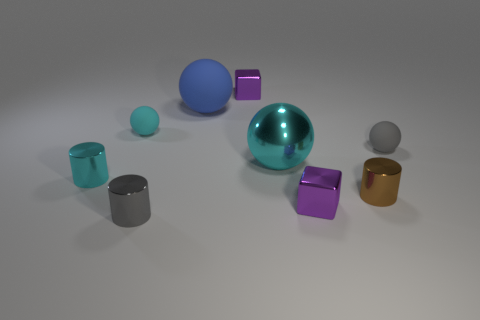Is the number of tiny brown cylinders that are behind the big cyan ball greater than the number of blue rubber balls?
Your answer should be compact. No. Is there any other thing that is the same size as the brown metal object?
Make the answer very short. Yes. There is a big rubber thing; is its color the same as the small rubber object left of the blue matte sphere?
Make the answer very short. No. Is the number of big blue balls left of the blue matte sphere the same as the number of small metal objects that are on the right side of the cyan rubber ball?
Offer a terse response. No. What is the small purple object that is in front of the tiny gray ball made of?
Your response must be concise. Metal. What number of things are cyan metallic spheres that are behind the tiny cyan shiny cylinder or small blue objects?
Your response must be concise. 1. How many other things are there of the same shape as the tiny gray rubber thing?
Ensure brevity in your answer.  3. There is a gray object that is behind the tiny gray metal thing; is its shape the same as the small gray metal thing?
Offer a very short reply. No. There is a big blue matte thing; are there any cyan shiny cylinders right of it?
Provide a succinct answer. No. What number of small things are rubber objects or metal things?
Make the answer very short. 7. 